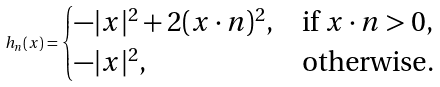Convert formula to latex. <formula><loc_0><loc_0><loc_500><loc_500>h _ { n } ( x ) = \begin{cases} - | x | ^ { 2 } + 2 ( x \cdot n ) ^ { 2 } , & \text {if $x\cdot n>0$} , \\ - | x | ^ { 2 } , & \text {otherwise} . \end{cases}</formula> 